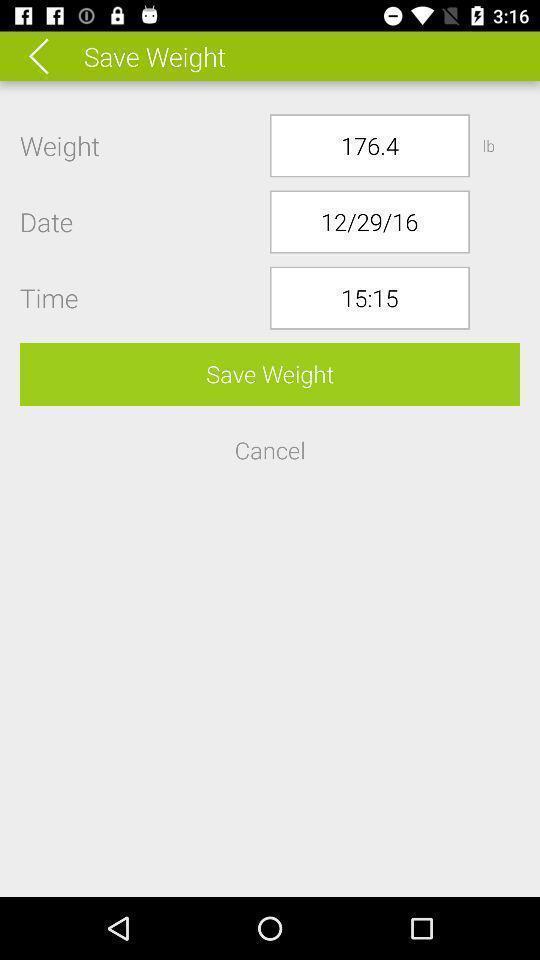Explain the elements present in this screenshot. Screen displaying weight details in a fitness app. 